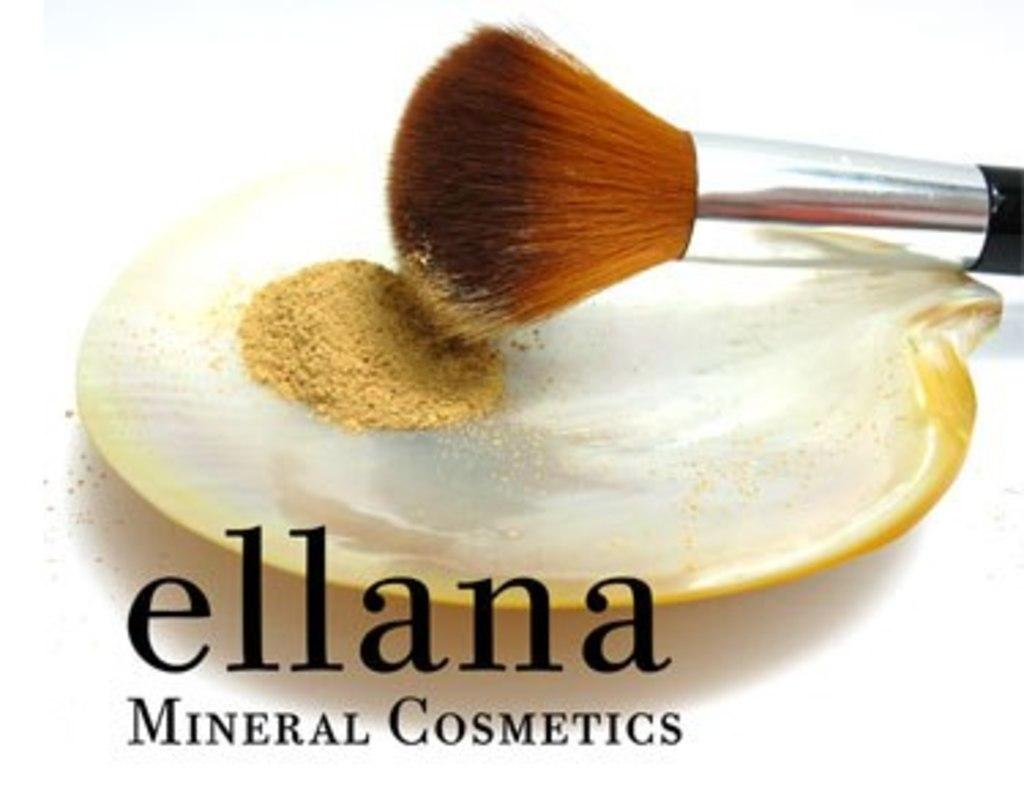What substance is visible in the image? There is powder in the image. What object is present in the image that might be used with the powder? There is a makeup brush in the image. What can be seen at the bottom of the image? There is text at the bottom of the image. What type of engine can be seen in the image? There is no engine present in the image. What type of learning material is visible in the image? There is no learning material present in the image. 